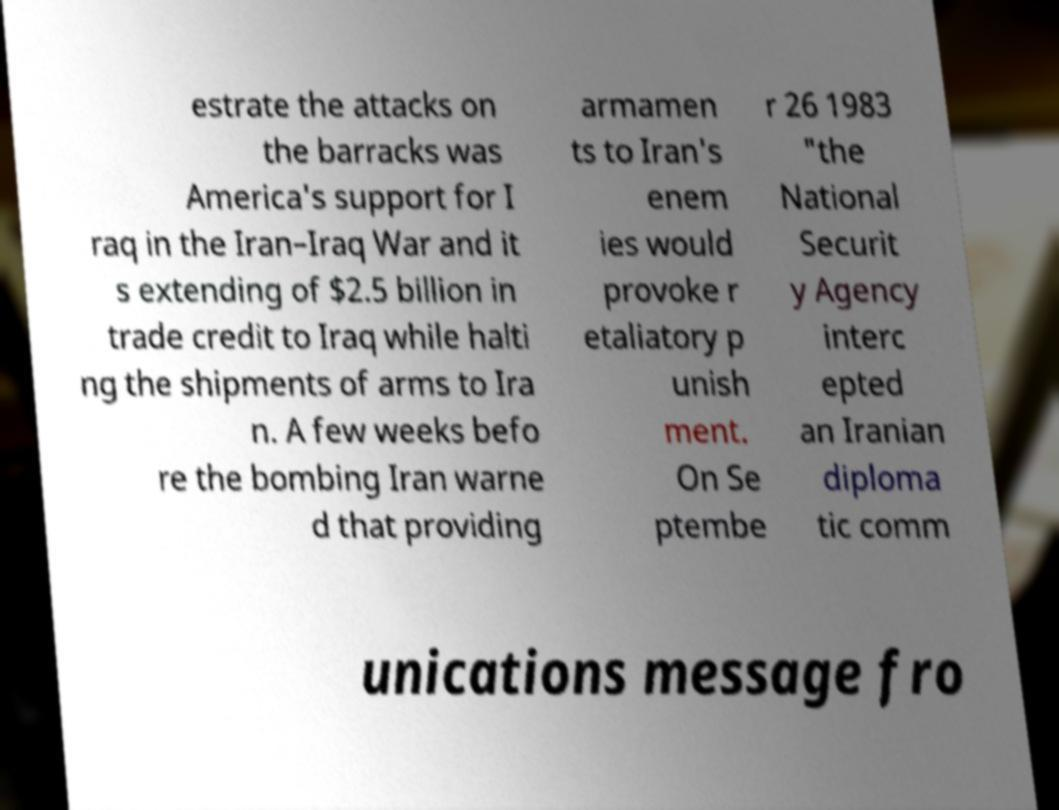Please identify and transcribe the text found in this image. estrate the attacks on the barracks was America's support for I raq in the Iran–Iraq War and it s extending of $2.5 billion in trade credit to Iraq while halti ng the shipments of arms to Ira n. A few weeks befo re the bombing Iran warne d that providing armamen ts to Iran's enem ies would provoke r etaliatory p unish ment. On Se ptembe r 26 1983 "the National Securit y Agency interc epted an Iranian diploma tic comm unications message fro 